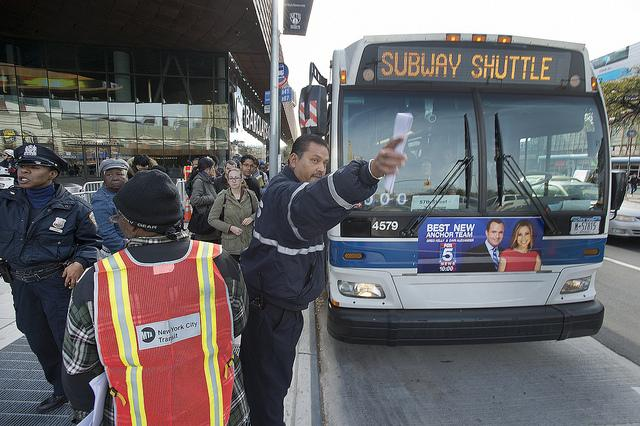What profession is the black man in the blue cap on the left?

Choices:
A) fireman
B) teacher
C) police officer
D) lawyer police officer 